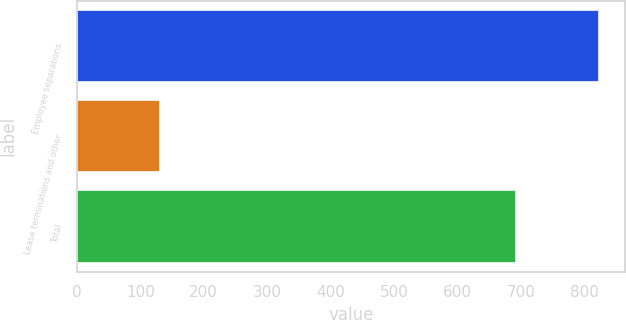Convert chart. <chart><loc_0><loc_0><loc_500><loc_500><bar_chart><fcel>Employee separations<fcel>Lease terminations and other<fcel>Total<nl><fcel>823<fcel>131<fcel>692<nl></chart> 